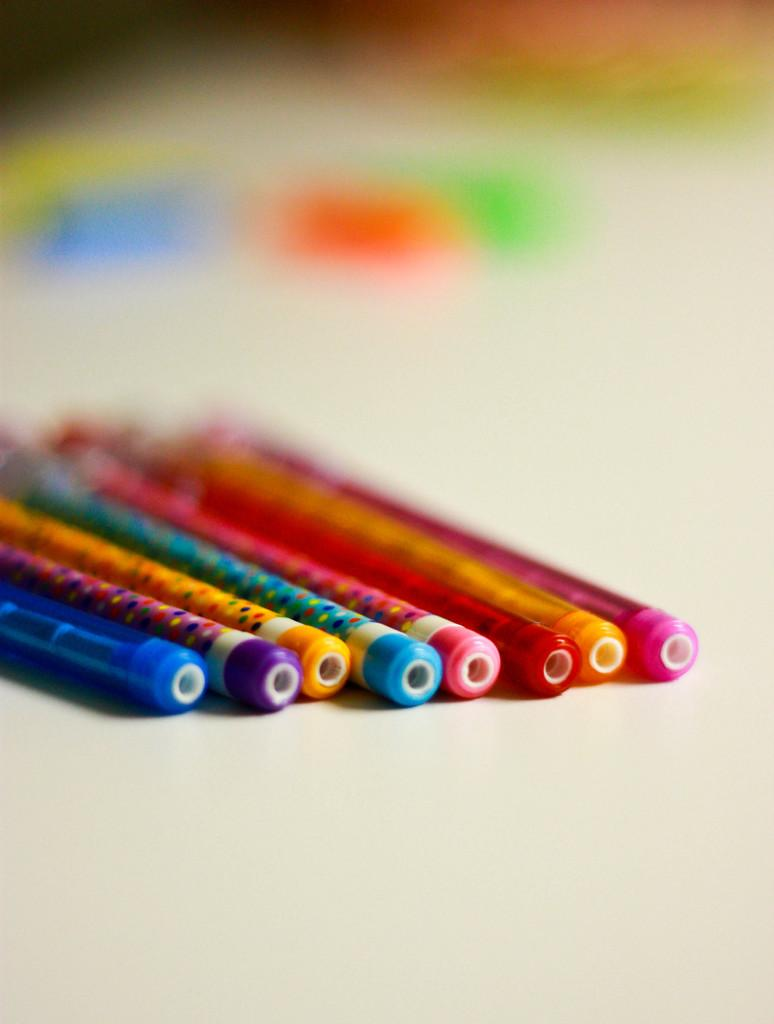What stationery items can be seen in the image? There are pens and pencils in the image. Are the pens and pencils of the same color? No, the pens and pencils are of different colors. What is the background of the image like? The background of the image is blurred. Can you see the veil on the pencil in the image? There is no veil present on the pencil in the image. What type of shoes are visible in the image? There are no shoes visible in the image. 